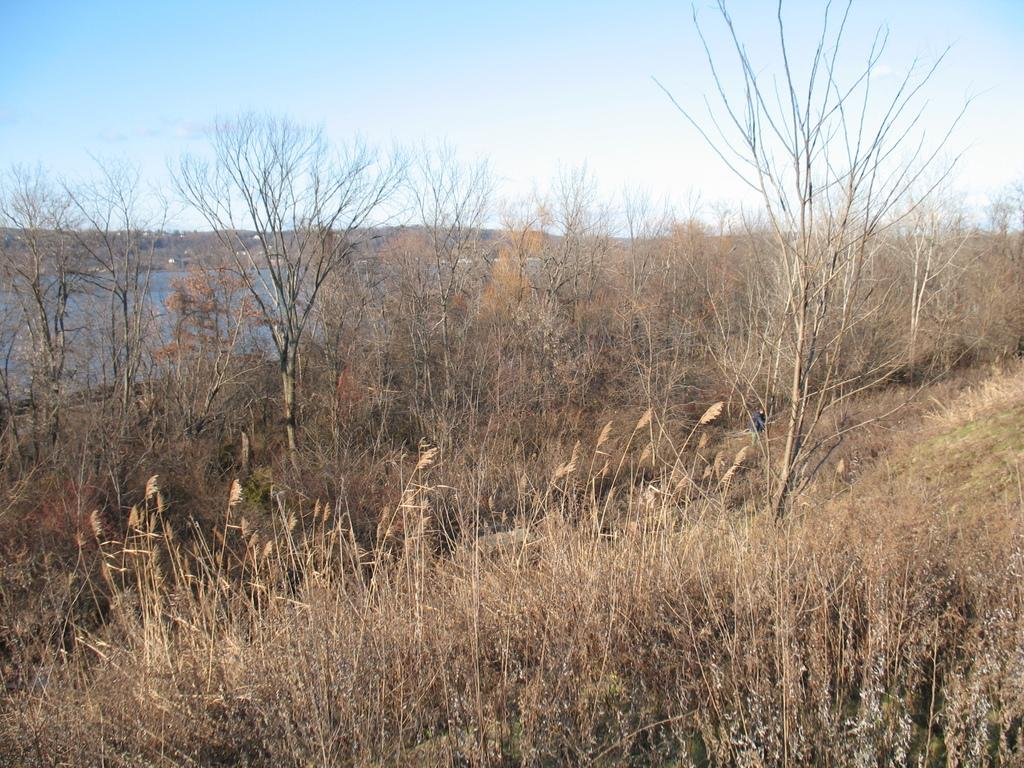What type of vegetation is present in the image? There is dried grass in the image. What else can be seen in the image besides the dried grass? There are branches of dried trees visible in the image. What is the water in the image used for? The water in the image is visible, but its purpose is not specified. What is visible at the top of the image? The sky is visible at the top of the image. Where is the pin located in the image? There is no pin present in the image. What type of office furniture can be seen in the image? There is no office furniture present in the image. 